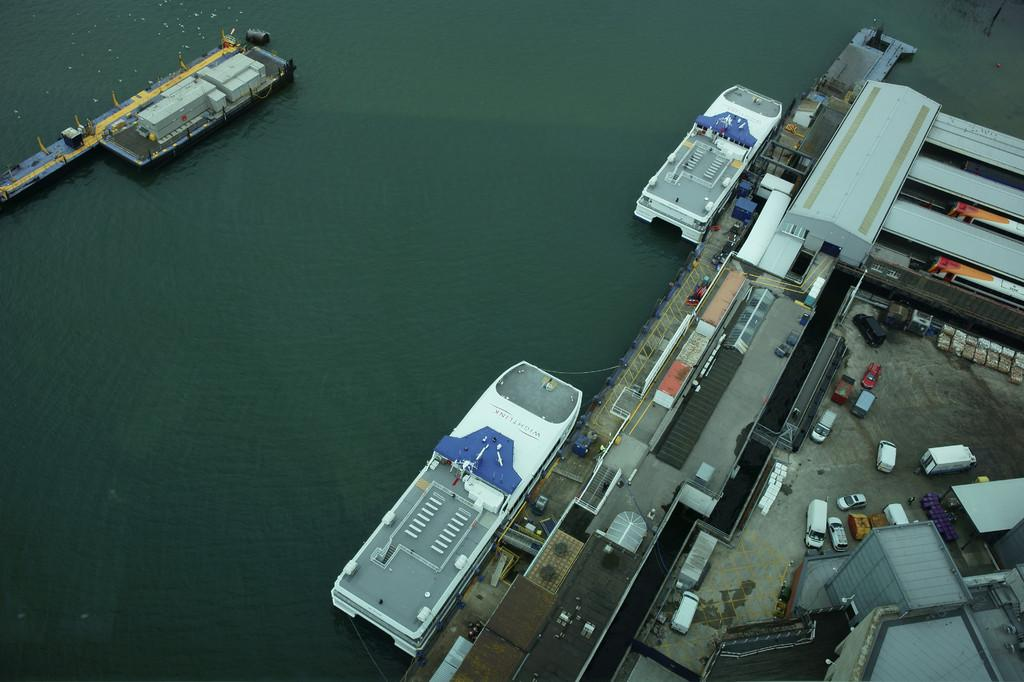What can be seen on the water in the image? There are ships on the water in the image. What type of structures are present in the image? There are sheds and a building in the image. What else can be seen in the image besides the ships and structures? There are vehicles and some objects in the image. Where are the sheds located in the image? The sheds are on a platform on the left side of the image. What committee is responsible for organizing the camp in the image? There is no mention of a committee or camp in the image; it features ships, sheds, a building, vehicles, and objects. 